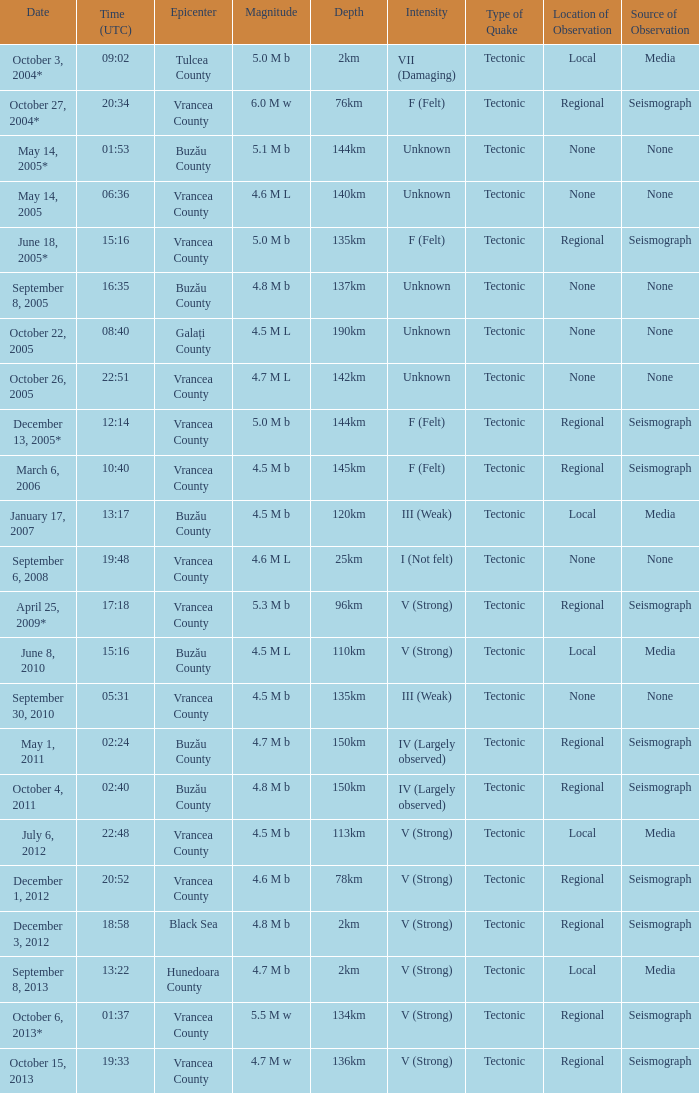Could you parse the entire table as a dict? {'header': ['Date', 'Time (UTC)', 'Epicenter', 'Magnitude', 'Depth', 'Intensity', 'Type of Quake', 'Location of Observation', 'Source of Observation'], 'rows': [['October 3, 2004*', '09:02', 'Tulcea County', '5.0 M b', '2km', 'VII (Damaging)', 'Tectonic', 'Local', 'Media'], ['October 27, 2004*', '20:34', 'Vrancea County', '6.0 M w', '76km', 'F (Felt)', 'Tectonic', 'Regional', 'Seismograph'], ['May 14, 2005*', '01:53', 'Buzău County', '5.1 M b', '144km', 'Unknown', 'Tectonic', 'None', 'None'], ['May 14, 2005', '06:36', 'Vrancea County', '4.6 M L', '140km', 'Unknown', 'Tectonic', 'None', 'None'], ['June 18, 2005*', '15:16', 'Vrancea County', '5.0 M b', '135km', 'F (Felt)', 'Tectonic', 'Regional', 'Seismograph'], ['September 8, 2005', '16:35', 'Buzău County', '4.8 M b', '137km', 'Unknown', 'Tectonic', 'None', 'None'], ['October 22, 2005', '08:40', 'Galați County', '4.5 M L', '190km', 'Unknown', 'Tectonic', 'None', 'None'], ['October 26, 2005', '22:51', 'Vrancea County', '4.7 M L', '142km', 'Unknown', 'Tectonic', 'None', 'None'], ['December 13, 2005*', '12:14', 'Vrancea County', '5.0 M b', '144km', 'F (Felt)', 'Tectonic', 'Regional', 'Seismograph'], ['March 6, 2006', '10:40', 'Vrancea County', '4.5 M b', '145km', 'F (Felt)', 'Tectonic', 'Regional', 'Seismograph'], ['January 17, 2007', '13:17', 'Buzău County', '4.5 M b', '120km', 'III (Weak)', 'Tectonic', 'Local', 'Media'], ['September 6, 2008', '19:48', 'Vrancea County', '4.6 M L', '25km', 'I (Not felt)', 'Tectonic', 'None', 'None'], ['April 25, 2009*', '17:18', 'Vrancea County', '5.3 M b', '96km', 'V (Strong)', 'Tectonic', 'Regional', 'Seismograph'], ['June 8, 2010', '15:16', 'Buzău County', '4.5 M L', '110km', 'V (Strong)', 'Tectonic', 'Local', 'Media'], ['September 30, 2010', '05:31', 'Vrancea County', '4.5 M b', '135km', 'III (Weak)', 'Tectonic', 'None', 'None'], ['May 1, 2011', '02:24', 'Buzău County', '4.7 M b', '150km', 'IV (Largely observed)', 'Tectonic', 'Regional', 'Seismograph'], ['October 4, 2011', '02:40', 'Buzău County', '4.8 M b', '150km', 'IV (Largely observed)', 'Tectonic', 'Regional', 'Seismograph'], ['July 6, 2012', '22:48', 'Vrancea County', '4.5 M b', '113km', 'V (Strong)', 'Tectonic', 'Local', 'Media'], ['December 1, 2012', '20:52', 'Vrancea County', '4.6 M b', '78km', 'V (Strong)', 'Tectonic', 'Regional', 'Seismograph'], ['December 3, 2012', '18:58', 'Black Sea', '4.8 M b', '2km', 'V (Strong)', 'Tectonic', 'Regional', 'Seismograph'], ['September 8, 2013', '13:22', 'Hunedoara County', '4.7 M b', '2km', 'V (Strong)', 'Tectonic', 'Local', 'Media'], ['October 6, 2013*', '01:37', 'Vrancea County', '5.5 M w', '134km', 'V (Strong)', 'Tectonic', 'Regional', 'Seismograph'], ['October 15, 2013', '19:33', 'Vrancea County', '4.7 M w', '136km', 'V (Strong)', 'Tectonic', 'Regional', 'Seismograph']]} What is the depth of the quake that occurred at 19:48? 25km. 